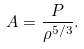<formula> <loc_0><loc_0><loc_500><loc_500>A = \frac { P } { \rho ^ { 5 / 3 } } .</formula> 